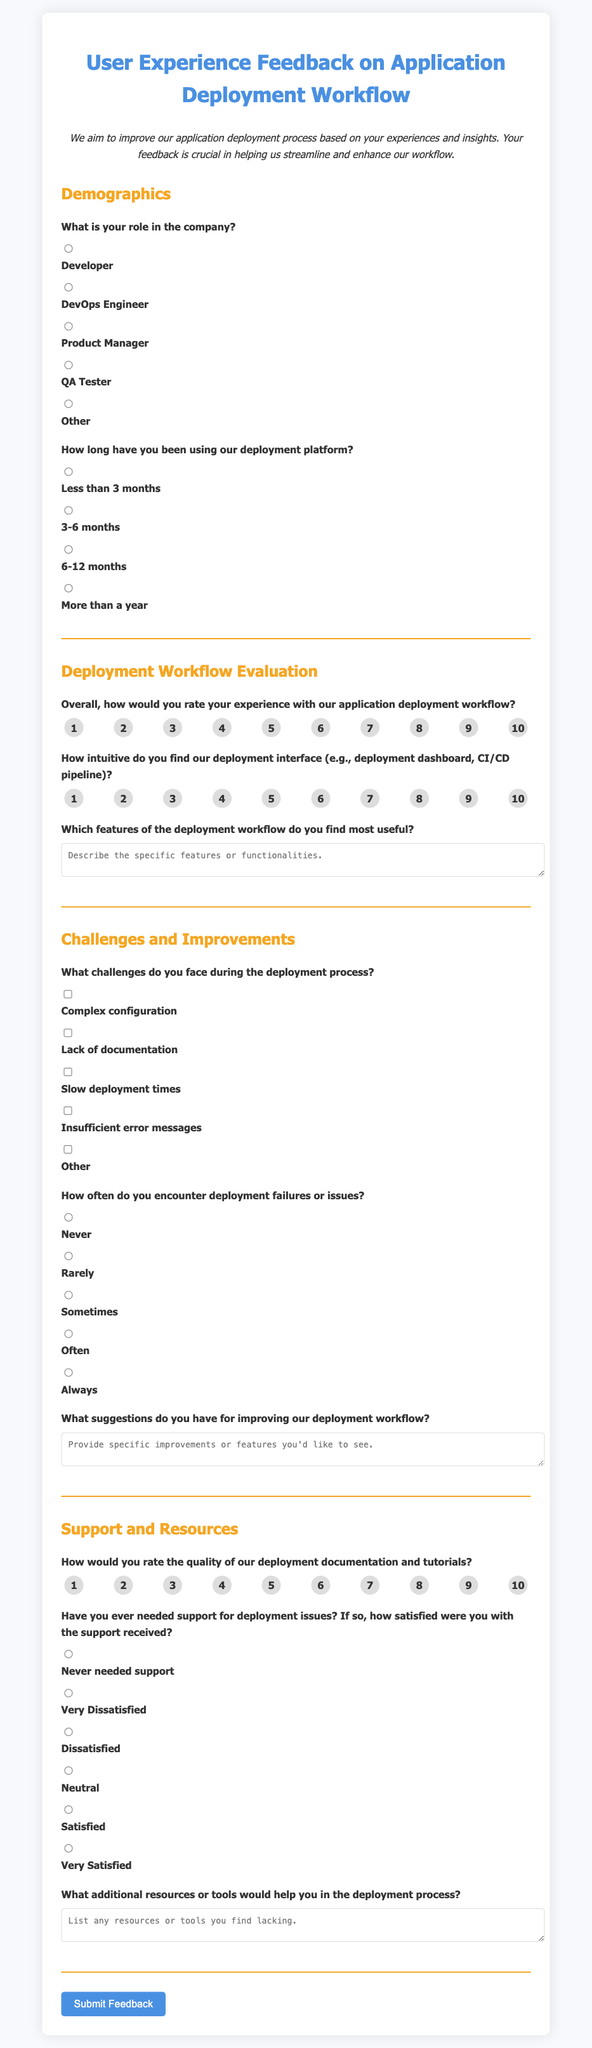What is the title of the survey? The title is stated clearly at the top of the document as it encapsulates the purpose of the survey.
Answer: User Experience Feedback on Application Deployment Workflow How many radio button options are there for the role question? The number of choices is determined by the provided options for the role in the company, which can be counted.
Answer: 5 What is the rating scale for overall experience? The rating scale is defined by the set of values provided for the experience rating question.
Answer: 1 to 10 What challenge option is related to documentation? The specific challenge mentioned in the survey that pertains to documentation can be directly identified from the checkbox options.
Answer: Lack of documentation Which section addresses improvement suggestions? The specific section where the participant is prompted to provide suggestions for improvements can be pinpointed.
Answer: Challenges and Improvements What is the highest rating option available for documentation quality? The highest point in the rating scale for documentation quality is indicated clearly among the radio button options.
Answer: 10 How many questions are there in the Support and Resources section? The total number of questions in this particular section can be counted.
Answer: 3 What is the prompt for the textarea about useful features? The exact phrase used as a prompt for this textarea can be referenced directly from the document.
Answer: Which features of the deployment workflow do you find most useful? What is the color scheme of the document based on the styles? The color scheme is a defined aspect of the visual style provided within the document.
Answer: Primary color is #4a90e2 and secondary color is #f5a623 